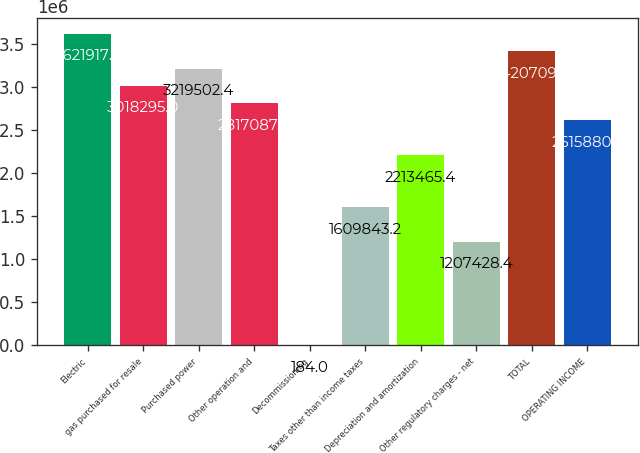Convert chart to OTSL. <chart><loc_0><loc_0><loc_500><loc_500><bar_chart><fcel>Electric<fcel>gas purchased for resale<fcel>Purchased power<fcel>Other operation and<fcel>Decommissioning<fcel>Taxes other than income taxes<fcel>Depreciation and amortization<fcel>Other regulatory charges - net<fcel>TOTAL<fcel>OPERATING INCOME<nl><fcel>3.62192e+06<fcel>3.0183e+06<fcel>3.2195e+06<fcel>2.81709e+06<fcel>184<fcel>1.60984e+06<fcel>2.21347e+06<fcel>1.20743e+06<fcel>3.42071e+06<fcel>2.61588e+06<nl></chart> 